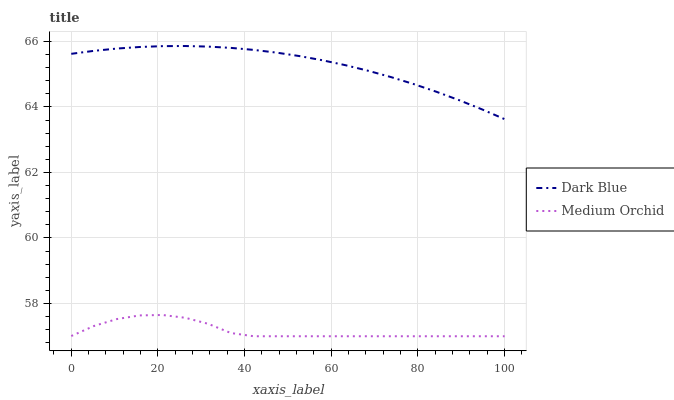Does Medium Orchid have the minimum area under the curve?
Answer yes or no. Yes. Does Dark Blue have the maximum area under the curve?
Answer yes or no. Yes. Does Medium Orchid have the maximum area under the curve?
Answer yes or no. No. Is Dark Blue the smoothest?
Answer yes or no. Yes. Is Medium Orchid the roughest?
Answer yes or no. Yes. Is Medium Orchid the smoothest?
Answer yes or no. No. Does Medium Orchid have the lowest value?
Answer yes or no. Yes. Does Dark Blue have the highest value?
Answer yes or no. Yes. Does Medium Orchid have the highest value?
Answer yes or no. No. Is Medium Orchid less than Dark Blue?
Answer yes or no. Yes. Is Dark Blue greater than Medium Orchid?
Answer yes or no. Yes. Does Medium Orchid intersect Dark Blue?
Answer yes or no. No. 